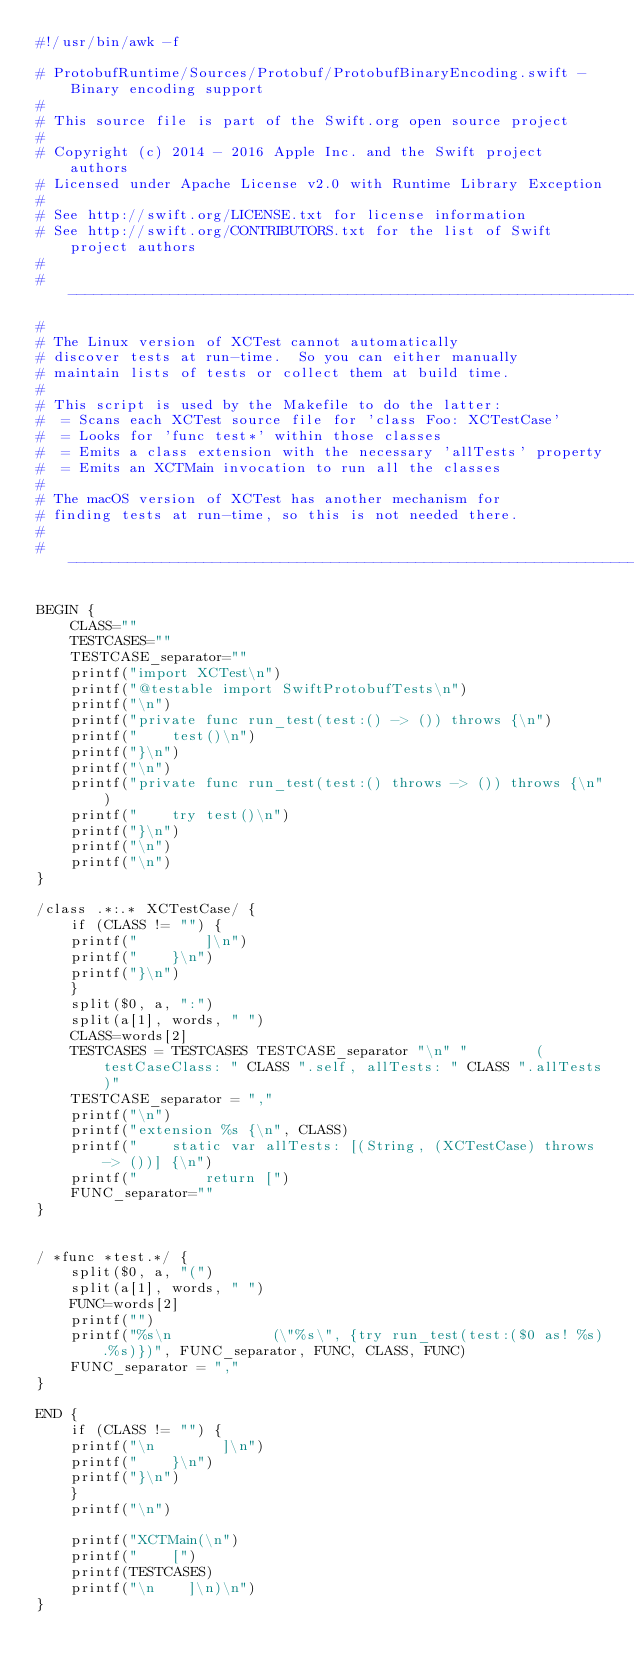<code> <loc_0><loc_0><loc_500><loc_500><_Awk_>#!/usr/bin/awk -f

# ProtobufRuntime/Sources/Protobuf/ProtobufBinaryEncoding.swift - Binary encoding support
#
# This source file is part of the Swift.org open source project
#
# Copyright (c) 2014 - 2016 Apple Inc. and the Swift project authors
# Licensed under Apache License v2.0 with Runtime Library Exception
#
# See http://swift.org/LICENSE.txt for license information
# See http://swift.org/CONTRIBUTORS.txt for the list of Swift project authors
#
# -----------------------------------------------------------------------------
#
# The Linux version of XCTest cannot automatically
# discover tests at run-time.  So you can either manually
# maintain lists of tests or collect them at build time.
#
# This script is used by the Makefile to do the latter:
#  = Scans each XCTest source file for 'class Foo: XCTestCase'
#  = Looks for 'func test*' within those classes
#  = Emits a class extension with the necessary 'allTests' property
#  = Emits an XCTMain invocation to run all the classes
#
# The macOS version of XCTest has another mechanism for
# finding tests at run-time, so this is not needed there.
#
# -----------------------------------------------------------------------------

BEGIN {
    CLASS=""
    TESTCASES=""
    TESTCASE_separator=""
    printf("import XCTest\n")
    printf("@testable import SwiftProtobufTests\n")
    printf("\n")
    printf("private func run_test(test:() -> ()) throws {\n")
    printf("    test()\n")
    printf("}\n")
    printf("\n")
    printf("private func run_test(test:() throws -> ()) throws {\n")
    printf("    try test()\n")
    printf("}\n")
    printf("\n")
    printf("\n")
}

/class .*:.* XCTestCase/ {
    if (CLASS != "") {
	printf("        ]\n")
	printf("    }\n")
	printf("}\n")
    }
    split($0, a, ":")
    split(a[1], words, " ")
    CLASS=words[2]
    TESTCASES = TESTCASES TESTCASE_separator "\n" "        (testCaseClass: " CLASS ".self, allTests: " CLASS ".allTests)"
    TESTCASE_separator = ","
    printf("\n")
    printf("extension %s {\n", CLASS)
    printf("    static var allTests: [(String, (XCTestCase) throws -> ())] {\n")
    printf("        return [")
    FUNC_separator=""
}


/ *func *test.*/ {
    split($0, a, "(")
    split(a[1], words, " ")
    FUNC=words[2]
    printf("")
    printf("%s\n            (\"%s\", {try run_test(test:($0 as! %s).%s)})", FUNC_separator, FUNC, CLASS, FUNC)
    FUNC_separator = ","
}

END {
    if (CLASS != "") {
	printf("\n        ]\n")
	printf("    }\n")
	printf("}\n")
    }
    printf("\n")

    printf("XCTMain(\n")
    printf("    [")
    printf(TESTCASES)
    printf("\n    ]\n)\n")
}
</code> 